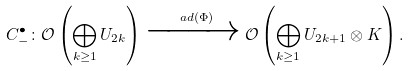<formula> <loc_0><loc_0><loc_500><loc_500>C ^ { \bullet } _ { - } \colon \mathcal { O } \left ( \bigoplus _ { k \geq 1 } U _ { 2 k } \right ) \xrightarrow { \ a d ( \Phi ) } \mathcal { O } \left ( \bigoplus _ { k \geq 1 } U _ { 2 k + 1 } \otimes K \right ) .</formula> 